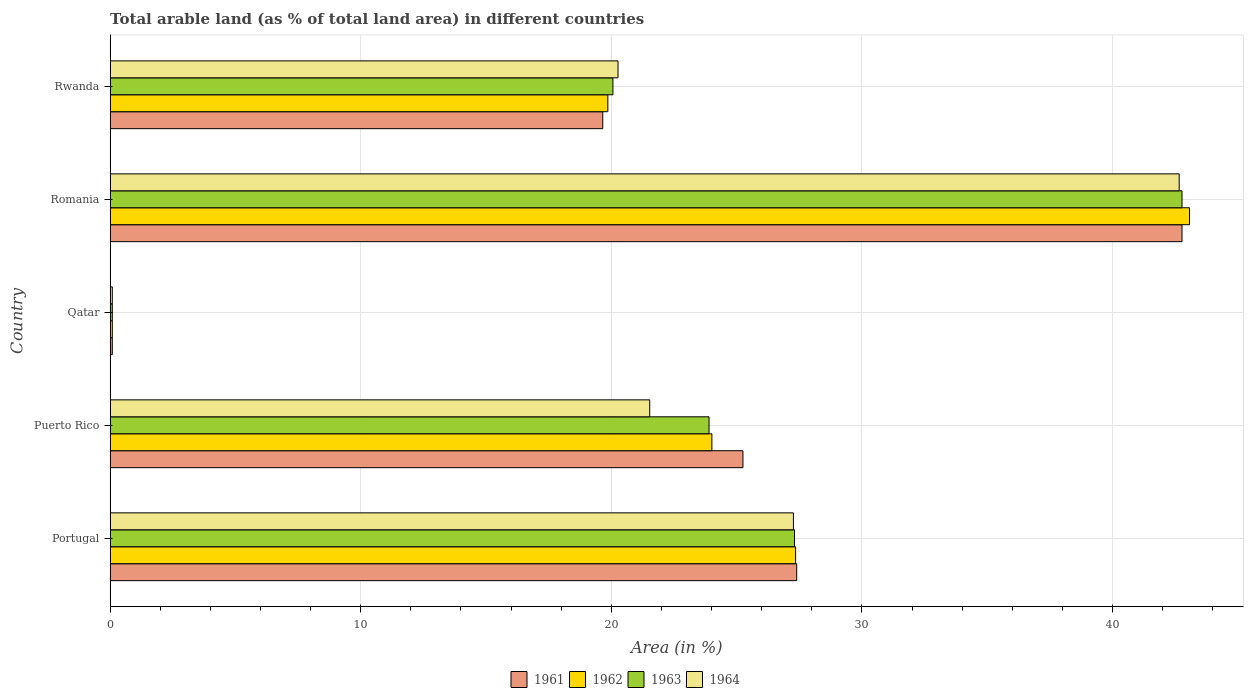How many different coloured bars are there?
Give a very brief answer. 4. How many groups of bars are there?
Your answer should be very brief. 5. Are the number of bars per tick equal to the number of legend labels?
Ensure brevity in your answer.  Yes. How many bars are there on the 3rd tick from the top?
Your response must be concise. 4. How many bars are there on the 2nd tick from the bottom?
Make the answer very short. 4. What is the label of the 4th group of bars from the top?
Make the answer very short. Puerto Rico. What is the percentage of arable land in 1961 in Rwanda?
Offer a terse response. 19.66. Across all countries, what is the maximum percentage of arable land in 1961?
Your answer should be very brief. 42.78. Across all countries, what is the minimum percentage of arable land in 1963?
Offer a terse response. 0.09. In which country was the percentage of arable land in 1964 maximum?
Provide a short and direct response. Romania. In which country was the percentage of arable land in 1963 minimum?
Provide a succinct answer. Qatar. What is the total percentage of arable land in 1963 in the graph?
Give a very brief answer. 114.14. What is the difference between the percentage of arable land in 1963 in Portugal and that in Rwanda?
Your answer should be compact. 7.25. What is the difference between the percentage of arable land in 1962 in Rwanda and the percentage of arable land in 1964 in Portugal?
Your response must be concise. -7.41. What is the average percentage of arable land in 1961 per country?
Offer a very short reply. 23.03. What is the ratio of the percentage of arable land in 1961 in Romania to that in Rwanda?
Offer a very short reply. 2.18. What is the difference between the highest and the second highest percentage of arable land in 1964?
Your answer should be very brief. 15.4. What is the difference between the highest and the lowest percentage of arable land in 1961?
Offer a terse response. 42.69. Is the sum of the percentage of arable land in 1964 in Puerto Rico and Qatar greater than the maximum percentage of arable land in 1961 across all countries?
Provide a succinct answer. No. Is it the case that in every country, the sum of the percentage of arable land in 1964 and percentage of arable land in 1962 is greater than the sum of percentage of arable land in 1961 and percentage of arable land in 1963?
Provide a short and direct response. No. What does the 4th bar from the top in Puerto Rico represents?
Your answer should be very brief. 1961. What does the 4th bar from the bottom in Rwanda represents?
Give a very brief answer. 1964. Is it the case that in every country, the sum of the percentage of arable land in 1961 and percentage of arable land in 1962 is greater than the percentage of arable land in 1964?
Ensure brevity in your answer.  Yes. How many bars are there?
Your answer should be compact. 20. Are all the bars in the graph horizontal?
Your answer should be compact. Yes. Does the graph contain any zero values?
Keep it short and to the point. No. Does the graph contain grids?
Your response must be concise. Yes. What is the title of the graph?
Offer a very short reply. Total arable land (as % of total land area) in different countries. Does "2000" appear as one of the legend labels in the graph?
Give a very brief answer. No. What is the label or title of the X-axis?
Your answer should be very brief. Area (in %). What is the label or title of the Y-axis?
Your answer should be compact. Country. What is the Area (in %) in 1961 in Portugal?
Your answer should be compact. 27.4. What is the Area (in %) in 1962 in Portugal?
Your response must be concise. 27.36. What is the Area (in %) of 1963 in Portugal?
Your response must be concise. 27.31. What is the Area (in %) in 1964 in Portugal?
Your answer should be compact. 27.27. What is the Area (in %) of 1961 in Puerto Rico?
Make the answer very short. 25.25. What is the Area (in %) of 1962 in Puerto Rico?
Provide a succinct answer. 24.01. What is the Area (in %) of 1963 in Puerto Rico?
Offer a terse response. 23.9. What is the Area (in %) in 1964 in Puerto Rico?
Your answer should be compact. 21.53. What is the Area (in %) of 1961 in Qatar?
Provide a short and direct response. 0.09. What is the Area (in %) in 1962 in Qatar?
Your response must be concise. 0.09. What is the Area (in %) of 1963 in Qatar?
Your response must be concise. 0.09. What is the Area (in %) in 1964 in Qatar?
Your answer should be very brief. 0.09. What is the Area (in %) in 1961 in Romania?
Keep it short and to the point. 42.78. What is the Area (in %) in 1962 in Romania?
Offer a terse response. 43.08. What is the Area (in %) of 1963 in Romania?
Your response must be concise. 42.78. What is the Area (in %) of 1964 in Romania?
Make the answer very short. 42.66. What is the Area (in %) in 1961 in Rwanda?
Your answer should be very brief. 19.66. What is the Area (in %) in 1962 in Rwanda?
Your response must be concise. 19.86. What is the Area (in %) of 1963 in Rwanda?
Offer a very short reply. 20.06. What is the Area (in %) in 1964 in Rwanda?
Make the answer very short. 20.27. Across all countries, what is the maximum Area (in %) of 1961?
Provide a short and direct response. 42.78. Across all countries, what is the maximum Area (in %) of 1962?
Ensure brevity in your answer.  43.08. Across all countries, what is the maximum Area (in %) of 1963?
Your answer should be compact. 42.78. Across all countries, what is the maximum Area (in %) of 1964?
Ensure brevity in your answer.  42.66. Across all countries, what is the minimum Area (in %) of 1961?
Provide a succinct answer. 0.09. Across all countries, what is the minimum Area (in %) in 1962?
Your answer should be compact. 0.09. Across all countries, what is the minimum Area (in %) of 1963?
Offer a very short reply. 0.09. Across all countries, what is the minimum Area (in %) of 1964?
Provide a short and direct response. 0.09. What is the total Area (in %) in 1961 in the graph?
Give a very brief answer. 115.17. What is the total Area (in %) in 1962 in the graph?
Provide a short and direct response. 114.39. What is the total Area (in %) of 1963 in the graph?
Offer a very short reply. 114.14. What is the total Area (in %) of 1964 in the graph?
Ensure brevity in your answer.  111.82. What is the difference between the Area (in %) of 1961 in Portugal and that in Puerto Rico?
Ensure brevity in your answer.  2.15. What is the difference between the Area (in %) in 1962 in Portugal and that in Puerto Rico?
Offer a terse response. 3.34. What is the difference between the Area (in %) in 1963 in Portugal and that in Puerto Rico?
Give a very brief answer. 3.41. What is the difference between the Area (in %) in 1964 in Portugal and that in Puerto Rico?
Give a very brief answer. 5.73. What is the difference between the Area (in %) in 1961 in Portugal and that in Qatar?
Give a very brief answer. 27.31. What is the difference between the Area (in %) of 1962 in Portugal and that in Qatar?
Give a very brief answer. 27.27. What is the difference between the Area (in %) in 1963 in Portugal and that in Qatar?
Offer a very short reply. 27.23. What is the difference between the Area (in %) in 1964 in Portugal and that in Qatar?
Your answer should be very brief. 27.18. What is the difference between the Area (in %) in 1961 in Portugal and that in Romania?
Your answer should be compact. -15.38. What is the difference between the Area (in %) of 1962 in Portugal and that in Romania?
Your response must be concise. -15.72. What is the difference between the Area (in %) of 1963 in Portugal and that in Romania?
Provide a succinct answer. -15.46. What is the difference between the Area (in %) of 1964 in Portugal and that in Romania?
Provide a short and direct response. -15.4. What is the difference between the Area (in %) in 1961 in Portugal and that in Rwanda?
Your response must be concise. 7.74. What is the difference between the Area (in %) in 1962 in Portugal and that in Rwanda?
Your answer should be very brief. 7.49. What is the difference between the Area (in %) in 1963 in Portugal and that in Rwanda?
Give a very brief answer. 7.25. What is the difference between the Area (in %) in 1964 in Portugal and that in Rwanda?
Your response must be concise. 7. What is the difference between the Area (in %) in 1961 in Puerto Rico and that in Qatar?
Give a very brief answer. 25.17. What is the difference between the Area (in %) of 1962 in Puerto Rico and that in Qatar?
Offer a very short reply. 23.93. What is the difference between the Area (in %) of 1963 in Puerto Rico and that in Qatar?
Offer a very short reply. 23.81. What is the difference between the Area (in %) of 1964 in Puerto Rico and that in Qatar?
Make the answer very short. 21.45. What is the difference between the Area (in %) of 1961 in Puerto Rico and that in Romania?
Provide a succinct answer. -17.52. What is the difference between the Area (in %) of 1962 in Puerto Rico and that in Romania?
Your response must be concise. -19.06. What is the difference between the Area (in %) of 1963 in Puerto Rico and that in Romania?
Your answer should be very brief. -18.88. What is the difference between the Area (in %) of 1964 in Puerto Rico and that in Romania?
Offer a terse response. -21.13. What is the difference between the Area (in %) in 1961 in Puerto Rico and that in Rwanda?
Give a very brief answer. 5.59. What is the difference between the Area (in %) of 1962 in Puerto Rico and that in Rwanda?
Offer a terse response. 4.15. What is the difference between the Area (in %) in 1963 in Puerto Rico and that in Rwanda?
Keep it short and to the point. 3.84. What is the difference between the Area (in %) of 1964 in Puerto Rico and that in Rwanda?
Make the answer very short. 1.27. What is the difference between the Area (in %) of 1961 in Qatar and that in Romania?
Make the answer very short. -42.69. What is the difference between the Area (in %) in 1962 in Qatar and that in Romania?
Your response must be concise. -42.99. What is the difference between the Area (in %) of 1963 in Qatar and that in Romania?
Make the answer very short. -42.69. What is the difference between the Area (in %) of 1964 in Qatar and that in Romania?
Provide a short and direct response. -42.58. What is the difference between the Area (in %) of 1961 in Qatar and that in Rwanda?
Give a very brief answer. -19.57. What is the difference between the Area (in %) of 1962 in Qatar and that in Rwanda?
Give a very brief answer. -19.78. What is the difference between the Area (in %) in 1963 in Qatar and that in Rwanda?
Provide a succinct answer. -19.98. What is the difference between the Area (in %) of 1964 in Qatar and that in Rwanda?
Your answer should be compact. -20.18. What is the difference between the Area (in %) in 1961 in Romania and that in Rwanda?
Offer a very short reply. 23.12. What is the difference between the Area (in %) in 1962 in Romania and that in Rwanda?
Offer a very short reply. 23.21. What is the difference between the Area (in %) in 1963 in Romania and that in Rwanda?
Ensure brevity in your answer.  22.71. What is the difference between the Area (in %) of 1964 in Romania and that in Rwanda?
Ensure brevity in your answer.  22.4. What is the difference between the Area (in %) in 1961 in Portugal and the Area (in %) in 1962 in Puerto Rico?
Your answer should be very brief. 3.39. What is the difference between the Area (in %) of 1961 in Portugal and the Area (in %) of 1963 in Puerto Rico?
Make the answer very short. 3.5. What is the difference between the Area (in %) in 1961 in Portugal and the Area (in %) in 1964 in Puerto Rico?
Provide a succinct answer. 5.87. What is the difference between the Area (in %) in 1962 in Portugal and the Area (in %) in 1963 in Puerto Rico?
Provide a short and direct response. 3.45. What is the difference between the Area (in %) of 1962 in Portugal and the Area (in %) of 1964 in Puerto Rico?
Provide a succinct answer. 5.82. What is the difference between the Area (in %) in 1963 in Portugal and the Area (in %) in 1964 in Puerto Rico?
Offer a very short reply. 5.78. What is the difference between the Area (in %) in 1961 in Portugal and the Area (in %) in 1962 in Qatar?
Provide a short and direct response. 27.31. What is the difference between the Area (in %) of 1961 in Portugal and the Area (in %) of 1963 in Qatar?
Keep it short and to the point. 27.31. What is the difference between the Area (in %) in 1961 in Portugal and the Area (in %) in 1964 in Qatar?
Make the answer very short. 27.31. What is the difference between the Area (in %) in 1962 in Portugal and the Area (in %) in 1963 in Qatar?
Ensure brevity in your answer.  27.27. What is the difference between the Area (in %) of 1962 in Portugal and the Area (in %) of 1964 in Qatar?
Your answer should be compact. 27.27. What is the difference between the Area (in %) of 1963 in Portugal and the Area (in %) of 1964 in Qatar?
Ensure brevity in your answer.  27.23. What is the difference between the Area (in %) in 1961 in Portugal and the Area (in %) in 1962 in Romania?
Offer a very short reply. -15.68. What is the difference between the Area (in %) in 1961 in Portugal and the Area (in %) in 1963 in Romania?
Your response must be concise. -15.38. What is the difference between the Area (in %) of 1961 in Portugal and the Area (in %) of 1964 in Romania?
Keep it short and to the point. -15.26. What is the difference between the Area (in %) in 1962 in Portugal and the Area (in %) in 1963 in Romania?
Give a very brief answer. -15.42. What is the difference between the Area (in %) in 1962 in Portugal and the Area (in %) in 1964 in Romania?
Provide a short and direct response. -15.31. What is the difference between the Area (in %) of 1963 in Portugal and the Area (in %) of 1964 in Romania?
Offer a very short reply. -15.35. What is the difference between the Area (in %) of 1961 in Portugal and the Area (in %) of 1962 in Rwanda?
Offer a terse response. 7.54. What is the difference between the Area (in %) in 1961 in Portugal and the Area (in %) in 1963 in Rwanda?
Your answer should be compact. 7.33. What is the difference between the Area (in %) of 1961 in Portugal and the Area (in %) of 1964 in Rwanda?
Give a very brief answer. 7.13. What is the difference between the Area (in %) in 1962 in Portugal and the Area (in %) in 1963 in Rwanda?
Make the answer very short. 7.29. What is the difference between the Area (in %) of 1962 in Portugal and the Area (in %) of 1964 in Rwanda?
Make the answer very short. 7.09. What is the difference between the Area (in %) of 1963 in Portugal and the Area (in %) of 1964 in Rwanda?
Offer a terse response. 7.04. What is the difference between the Area (in %) in 1961 in Puerto Rico and the Area (in %) in 1962 in Qatar?
Your response must be concise. 25.17. What is the difference between the Area (in %) in 1961 in Puerto Rico and the Area (in %) in 1963 in Qatar?
Offer a very short reply. 25.17. What is the difference between the Area (in %) of 1961 in Puerto Rico and the Area (in %) of 1964 in Qatar?
Provide a succinct answer. 25.17. What is the difference between the Area (in %) in 1962 in Puerto Rico and the Area (in %) in 1963 in Qatar?
Ensure brevity in your answer.  23.93. What is the difference between the Area (in %) in 1962 in Puerto Rico and the Area (in %) in 1964 in Qatar?
Keep it short and to the point. 23.93. What is the difference between the Area (in %) in 1963 in Puerto Rico and the Area (in %) in 1964 in Qatar?
Give a very brief answer. 23.81. What is the difference between the Area (in %) in 1961 in Puerto Rico and the Area (in %) in 1962 in Romania?
Ensure brevity in your answer.  -17.82. What is the difference between the Area (in %) of 1961 in Puerto Rico and the Area (in %) of 1963 in Romania?
Give a very brief answer. -17.52. What is the difference between the Area (in %) in 1961 in Puerto Rico and the Area (in %) in 1964 in Romania?
Your answer should be compact. -17.41. What is the difference between the Area (in %) in 1962 in Puerto Rico and the Area (in %) in 1963 in Romania?
Your response must be concise. -18.76. What is the difference between the Area (in %) of 1962 in Puerto Rico and the Area (in %) of 1964 in Romania?
Make the answer very short. -18.65. What is the difference between the Area (in %) of 1963 in Puerto Rico and the Area (in %) of 1964 in Romania?
Make the answer very short. -18.76. What is the difference between the Area (in %) of 1961 in Puerto Rico and the Area (in %) of 1962 in Rwanda?
Your response must be concise. 5.39. What is the difference between the Area (in %) in 1961 in Puerto Rico and the Area (in %) in 1963 in Rwanda?
Offer a terse response. 5.19. What is the difference between the Area (in %) of 1961 in Puerto Rico and the Area (in %) of 1964 in Rwanda?
Ensure brevity in your answer.  4.99. What is the difference between the Area (in %) in 1962 in Puerto Rico and the Area (in %) in 1963 in Rwanda?
Provide a short and direct response. 3.95. What is the difference between the Area (in %) of 1962 in Puerto Rico and the Area (in %) of 1964 in Rwanda?
Ensure brevity in your answer.  3.75. What is the difference between the Area (in %) of 1963 in Puerto Rico and the Area (in %) of 1964 in Rwanda?
Offer a terse response. 3.63. What is the difference between the Area (in %) of 1961 in Qatar and the Area (in %) of 1962 in Romania?
Provide a short and direct response. -42.99. What is the difference between the Area (in %) in 1961 in Qatar and the Area (in %) in 1963 in Romania?
Ensure brevity in your answer.  -42.69. What is the difference between the Area (in %) in 1961 in Qatar and the Area (in %) in 1964 in Romania?
Make the answer very short. -42.58. What is the difference between the Area (in %) in 1962 in Qatar and the Area (in %) in 1963 in Romania?
Offer a terse response. -42.69. What is the difference between the Area (in %) of 1962 in Qatar and the Area (in %) of 1964 in Romania?
Your answer should be very brief. -42.58. What is the difference between the Area (in %) of 1963 in Qatar and the Area (in %) of 1964 in Romania?
Provide a succinct answer. -42.58. What is the difference between the Area (in %) of 1961 in Qatar and the Area (in %) of 1962 in Rwanda?
Offer a very short reply. -19.78. What is the difference between the Area (in %) of 1961 in Qatar and the Area (in %) of 1963 in Rwanda?
Provide a succinct answer. -19.98. What is the difference between the Area (in %) in 1961 in Qatar and the Area (in %) in 1964 in Rwanda?
Offer a terse response. -20.18. What is the difference between the Area (in %) in 1962 in Qatar and the Area (in %) in 1963 in Rwanda?
Ensure brevity in your answer.  -19.98. What is the difference between the Area (in %) in 1962 in Qatar and the Area (in %) in 1964 in Rwanda?
Your answer should be very brief. -20.18. What is the difference between the Area (in %) of 1963 in Qatar and the Area (in %) of 1964 in Rwanda?
Provide a short and direct response. -20.18. What is the difference between the Area (in %) of 1961 in Romania and the Area (in %) of 1962 in Rwanda?
Give a very brief answer. 22.91. What is the difference between the Area (in %) in 1961 in Romania and the Area (in %) in 1963 in Rwanda?
Your answer should be compact. 22.71. What is the difference between the Area (in %) in 1961 in Romania and the Area (in %) in 1964 in Rwanda?
Your response must be concise. 22.51. What is the difference between the Area (in %) in 1962 in Romania and the Area (in %) in 1963 in Rwanda?
Keep it short and to the point. 23.01. What is the difference between the Area (in %) in 1962 in Romania and the Area (in %) in 1964 in Rwanda?
Your response must be concise. 22.81. What is the difference between the Area (in %) of 1963 in Romania and the Area (in %) of 1964 in Rwanda?
Offer a very short reply. 22.51. What is the average Area (in %) of 1961 per country?
Ensure brevity in your answer.  23.03. What is the average Area (in %) in 1962 per country?
Provide a succinct answer. 22.88. What is the average Area (in %) of 1963 per country?
Your response must be concise. 22.83. What is the average Area (in %) in 1964 per country?
Your answer should be very brief. 22.36. What is the difference between the Area (in %) in 1961 and Area (in %) in 1962 in Portugal?
Your answer should be very brief. 0.04. What is the difference between the Area (in %) of 1961 and Area (in %) of 1963 in Portugal?
Offer a very short reply. 0.09. What is the difference between the Area (in %) of 1961 and Area (in %) of 1964 in Portugal?
Provide a short and direct response. 0.13. What is the difference between the Area (in %) of 1962 and Area (in %) of 1963 in Portugal?
Ensure brevity in your answer.  0.04. What is the difference between the Area (in %) in 1962 and Area (in %) in 1964 in Portugal?
Your response must be concise. 0.09. What is the difference between the Area (in %) in 1963 and Area (in %) in 1964 in Portugal?
Offer a terse response. 0.04. What is the difference between the Area (in %) in 1961 and Area (in %) in 1962 in Puerto Rico?
Offer a terse response. 1.24. What is the difference between the Area (in %) of 1961 and Area (in %) of 1963 in Puerto Rico?
Provide a succinct answer. 1.35. What is the difference between the Area (in %) in 1961 and Area (in %) in 1964 in Puerto Rico?
Provide a succinct answer. 3.72. What is the difference between the Area (in %) in 1962 and Area (in %) in 1963 in Puerto Rico?
Provide a short and direct response. 0.11. What is the difference between the Area (in %) of 1962 and Area (in %) of 1964 in Puerto Rico?
Provide a short and direct response. 2.48. What is the difference between the Area (in %) in 1963 and Area (in %) in 1964 in Puerto Rico?
Offer a terse response. 2.37. What is the difference between the Area (in %) of 1961 and Area (in %) of 1962 in Romania?
Provide a succinct answer. -0.3. What is the difference between the Area (in %) of 1961 and Area (in %) of 1964 in Romania?
Offer a very short reply. 0.11. What is the difference between the Area (in %) of 1962 and Area (in %) of 1963 in Romania?
Ensure brevity in your answer.  0.3. What is the difference between the Area (in %) of 1962 and Area (in %) of 1964 in Romania?
Keep it short and to the point. 0.41. What is the difference between the Area (in %) in 1963 and Area (in %) in 1964 in Romania?
Ensure brevity in your answer.  0.11. What is the difference between the Area (in %) of 1961 and Area (in %) of 1962 in Rwanda?
Your answer should be compact. -0.2. What is the difference between the Area (in %) in 1961 and Area (in %) in 1963 in Rwanda?
Provide a short and direct response. -0.41. What is the difference between the Area (in %) of 1961 and Area (in %) of 1964 in Rwanda?
Your answer should be very brief. -0.61. What is the difference between the Area (in %) in 1962 and Area (in %) in 1963 in Rwanda?
Provide a succinct answer. -0.2. What is the difference between the Area (in %) of 1962 and Area (in %) of 1964 in Rwanda?
Keep it short and to the point. -0.41. What is the difference between the Area (in %) in 1963 and Area (in %) in 1964 in Rwanda?
Give a very brief answer. -0.2. What is the ratio of the Area (in %) in 1961 in Portugal to that in Puerto Rico?
Offer a very short reply. 1.08. What is the ratio of the Area (in %) of 1962 in Portugal to that in Puerto Rico?
Your response must be concise. 1.14. What is the ratio of the Area (in %) in 1963 in Portugal to that in Puerto Rico?
Provide a short and direct response. 1.14. What is the ratio of the Area (in %) of 1964 in Portugal to that in Puerto Rico?
Your response must be concise. 1.27. What is the ratio of the Area (in %) in 1961 in Portugal to that in Qatar?
Give a very brief answer. 318.1. What is the ratio of the Area (in %) of 1962 in Portugal to that in Qatar?
Offer a terse response. 317.59. What is the ratio of the Area (in %) of 1963 in Portugal to that in Qatar?
Give a very brief answer. 317.09. What is the ratio of the Area (in %) of 1964 in Portugal to that in Qatar?
Provide a short and direct response. 316.58. What is the ratio of the Area (in %) in 1961 in Portugal to that in Romania?
Make the answer very short. 0.64. What is the ratio of the Area (in %) of 1962 in Portugal to that in Romania?
Offer a terse response. 0.64. What is the ratio of the Area (in %) of 1963 in Portugal to that in Romania?
Your response must be concise. 0.64. What is the ratio of the Area (in %) of 1964 in Portugal to that in Romania?
Keep it short and to the point. 0.64. What is the ratio of the Area (in %) in 1961 in Portugal to that in Rwanda?
Offer a very short reply. 1.39. What is the ratio of the Area (in %) in 1962 in Portugal to that in Rwanda?
Give a very brief answer. 1.38. What is the ratio of the Area (in %) in 1963 in Portugal to that in Rwanda?
Offer a very short reply. 1.36. What is the ratio of the Area (in %) of 1964 in Portugal to that in Rwanda?
Provide a succinct answer. 1.35. What is the ratio of the Area (in %) in 1961 in Puerto Rico to that in Qatar?
Give a very brief answer. 293.19. What is the ratio of the Area (in %) in 1962 in Puerto Rico to that in Qatar?
Offer a terse response. 278.8. What is the ratio of the Area (in %) of 1963 in Puerto Rico to that in Qatar?
Provide a succinct answer. 277.49. What is the ratio of the Area (in %) of 1964 in Puerto Rico to that in Qatar?
Your response must be concise. 250. What is the ratio of the Area (in %) in 1961 in Puerto Rico to that in Romania?
Offer a very short reply. 0.59. What is the ratio of the Area (in %) in 1962 in Puerto Rico to that in Romania?
Offer a very short reply. 0.56. What is the ratio of the Area (in %) in 1963 in Puerto Rico to that in Romania?
Keep it short and to the point. 0.56. What is the ratio of the Area (in %) in 1964 in Puerto Rico to that in Romania?
Your answer should be very brief. 0.5. What is the ratio of the Area (in %) in 1961 in Puerto Rico to that in Rwanda?
Your answer should be very brief. 1.28. What is the ratio of the Area (in %) of 1962 in Puerto Rico to that in Rwanda?
Offer a terse response. 1.21. What is the ratio of the Area (in %) in 1963 in Puerto Rico to that in Rwanda?
Keep it short and to the point. 1.19. What is the ratio of the Area (in %) of 1964 in Puerto Rico to that in Rwanda?
Keep it short and to the point. 1.06. What is the ratio of the Area (in %) in 1961 in Qatar to that in Romania?
Your answer should be very brief. 0. What is the ratio of the Area (in %) of 1962 in Qatar to that in Romania?
Offer a very short reply. 0. What is the ratio of the Area (in %) in 1963 in Qatar to that in Romania?
Offer a terse response. 0. What is the ratio of the Area (in %) in 1964 in Qatar to that in Romania?
Your answer should be very brief. 0. What is the ratio of the Area (in %) of 1961 in Qatar to that in Rwanda?
Your response must be concise. 0. What is the ratio of the Area (in %) in 1962 in Qatar to that in Rwanda?
Make the answer very short. 0. What is the ratio of the Area (in %) of 1963 in Qatar to that in Rwanda?
Ensure brevity in your answer.  0. What is the ratio of the Area (in %) in 1964 in Qatar to that in Rwanda?
Provide a short and direct response. 0. What is the ratio of the Area (in %) of 1961 in Romania to that in Rwanda?
Your response must be concise. 2.18. What is the ratio of the Area (in %) of 1962 in Romania to that in Rwanda?
Your answer should be very brief. 2.17. What is the ratio of the Area (in %) in 1963 in Romania to that in Rwanda?
Provide a short and direct response. 2.13. What is the ratio of the Area (in %) in 1964 in Romania to that in Rwanda?
Ensure brevity in your answer.  2.1. What is the difference between the highest and the second highest Area (in %) of 1961?
Give a very brief answer. 15.38. What is the difference between the highest and the second highest Area (in %) in 1962?
Your answer should be compact. 15.72. What is the difference between the highest and the second highest Area (in %) of 1963?
Offer a terse response. 15.46. What is the difference between the highest and the second highest Area (in %) of 1964?
Your answer should be compact. 15.4. What is the difference between the highest and the lowest Area (in %) of 1961?
Your answer should be compact. 42.69. What is the difference between the highest and the lowest Area (in %) in 1962?
Keep it short and to the point. 42.99. What is the difference between the highest and the lowest Area (in %) of 1963?
Your response must be concise. 42.69. What is the difference between the highest and the lowest Area (in %) of 1964?
Your answer should be very brief. 42.58. 